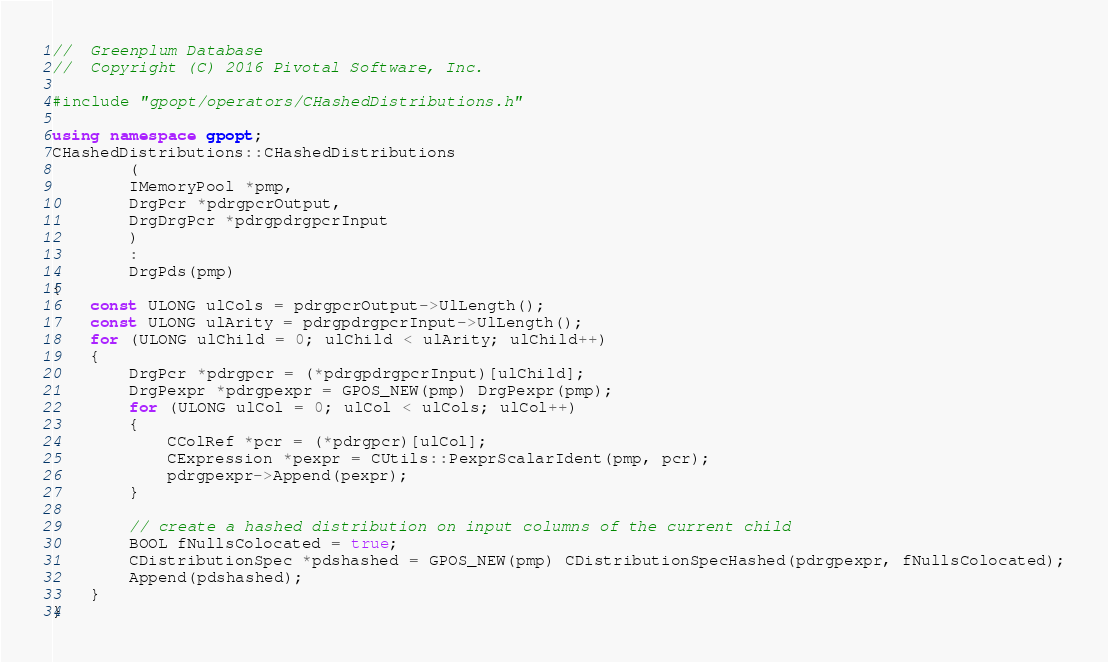<code> <loc_0><loc_0><loc_500><loc_500><_C++_>//	Greenplum Database
//	Copyright (C) 2016 Pivotal Software, Inc.

#include "gpopt/operators/CHashedDistributions.h"

using namespace gpopt;
CHashedDistributions::CHashedDistributions
		(
		IMemoryPool *pmp,
		DrgPcr *pdrgpcrOutput,
		DrgDrgPcr *pdrgpdrgpcrInput
		)
		:
		DrgPds(pmp)
{
	const ULONG ulCols = pdrgpcrOutput->UlLength();
	const ULONG ulArity = pdrgpdrgpcrInput->UlLength();
	for (ULONG ulChild = 0; ulChild < ulArity; ulChild++)
	{
		DrgPcr *pdrgpcr = (*pdrgpdrgpcrInput)[ulChild];
		DrgPexpr *pdrgpexpr = GPOS_NEW(pmp) DrgPexpr(pmp);
		for (ULONG ulCol = 0; ulCol < ulCols; ulCol++)
		{
			CColRef *pcr = (*pdrgpcr)[ulCol];
			CExpression *pexpr = CUtils::PexprScalarIdent(pmp, pcr);
			pdrgpexpr->Append(pexpr);
		}

		// create a hashed distribution on input columns of the current child
		BOOL fNullsColocated = true;
		CDistributionSpec *pdshashed = GPOS_NEW(pmp) CDistributionSpecHashed(pdrgpexpr, fNullsColocated);
		Append(pdshashed);
	}
}
</code> 